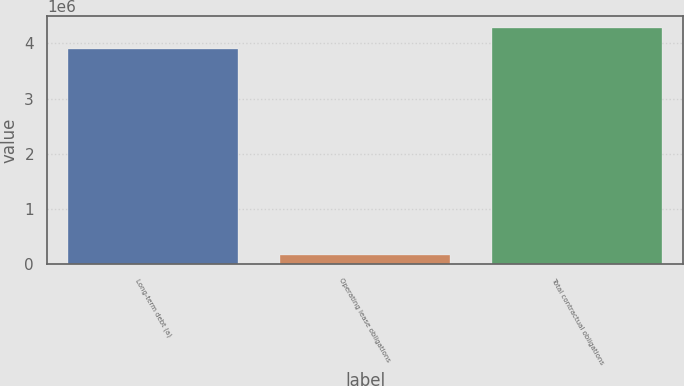Convert chart to OTSL. <chart><loc_0><loc_0><loc_500><loc_500><bar_chart><fcel>Long-term debt (a)<fcel>Operating lease obligations<fcel>Total contractual obligations<nl><fcel>3.89207e+06<fcel>160808<fcel>4.28203e+06<nl></chart> 